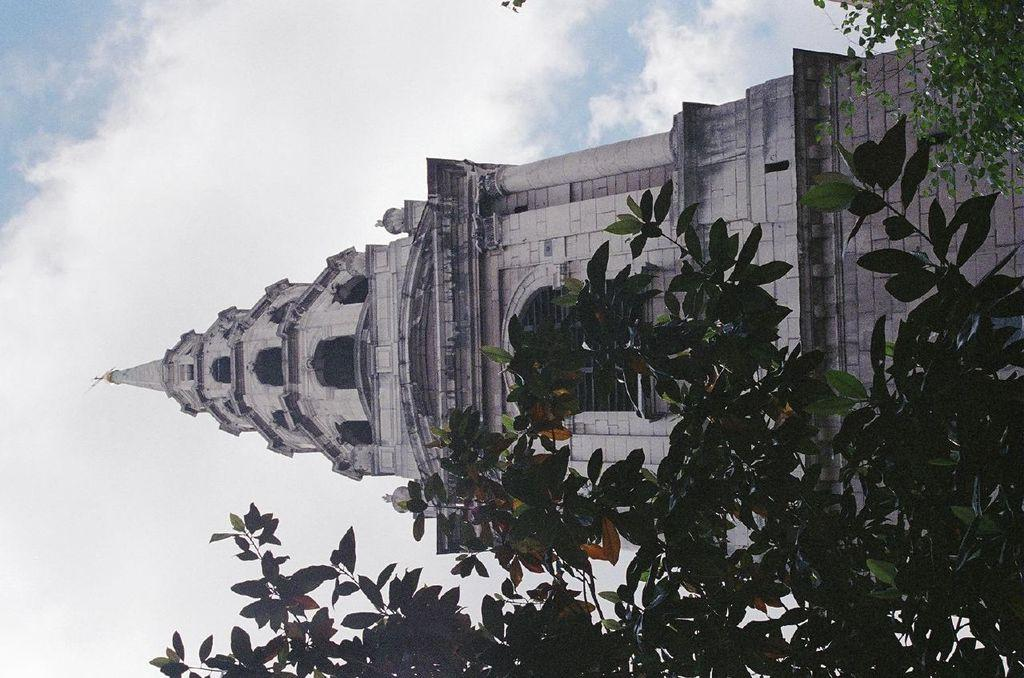What type of natural elements can be seen in the image? There are trees in the image. What type of man-made structure is present in the image? There is a huge building in the image. What can be seen in the background of the image? The sky is visible in the background of the image. Are there any plastic ducks floating in the trees in the image? There are no ducks, plastic or otherwise, present in the image. The image features trees and a huge building, with the sky visible in the background. 